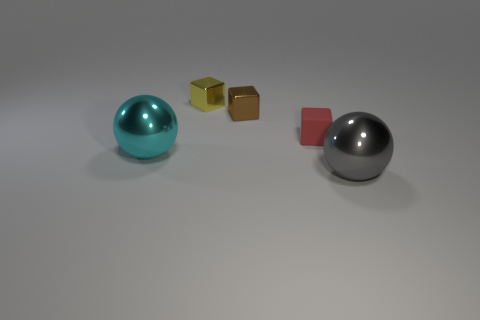The yellow object is what size?
Your answer should be compact. Small. How many things are small yellow balls or things that are in front of the small red object?
Provide a short and direct response. 2. There is a big metallic sphere on the right side of the brown object behind the rubber thing; what number of metallic things are on the left side of it?
Offer a terse response. 3. What number of tiny yellow metallic objects are there?
Make the answer very short. 1. There is a object in front of the cyan metal thing; does it have the same size as the small yellow object?
Your answer should be very brief. No. What number of metal things are big gray blocks or large cyan objects?
Ensure brevity in your answer.  1. What number of gray balls are to the right of the small object to the left of the brown cube?
Offer a very short reply. 1. What is the shape of the object that is both in front of the tiny yellow cube and behind the tiny red rubber object?
Your answer should be very brief. Cube. What is the material of the big thing that is left of the thing that is in front of the large ball that is to the left of the brown metal cube?
Offer a very short reply. Metal. What is the small yellow cube made of?
Offer a very short reply. Metal. 